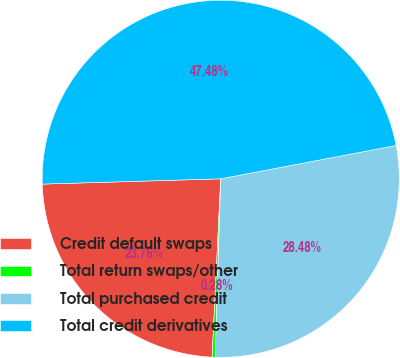Convert chart. <chart><loc_0><loc_0><loc_500><loc_500><pie_chart><fcel>Credit default swaps<fcel>Total return swaps/other<fcel>Total purchased credit<fcel>Total credit derivatives<nl><fcel>23.76%<fcel>0.28%<fcel>28.48%<fcel>47.48%<nl></chart> 